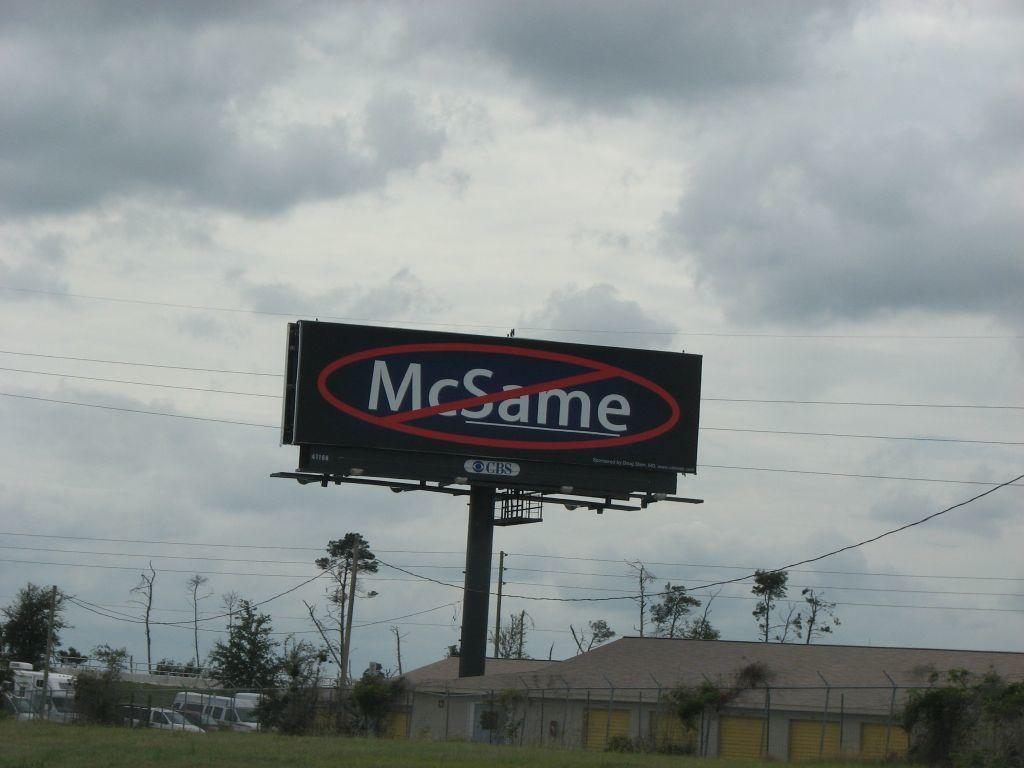<image>
Present a compact description of the photo's key features. A large bill board with the letters CBS at the bottom. 